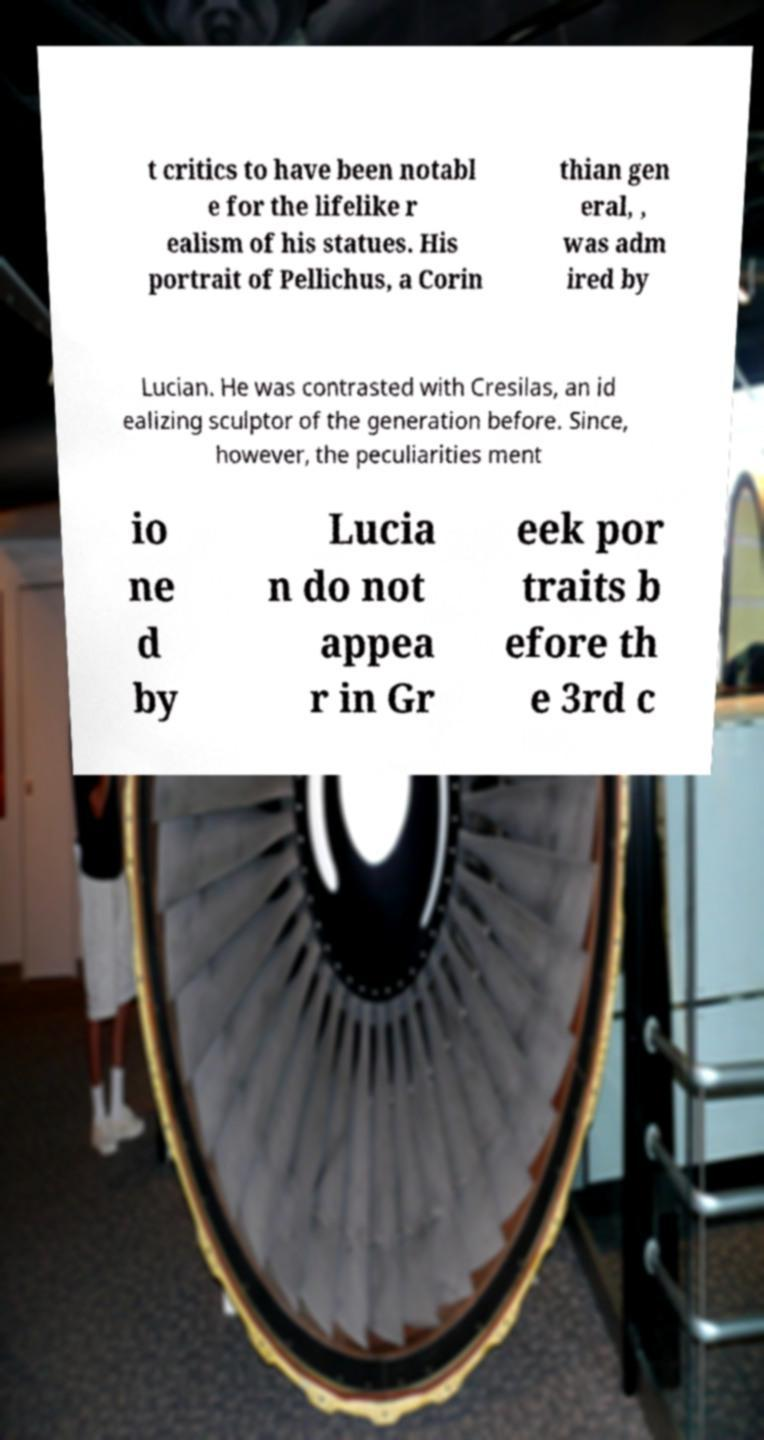Could you assist in decoding the text presented in this image and type it out clearly? t critics to have been notabl e for the lifelike r ealism of his statues. His portrait of Pellichus, a Corin thian gen eral, , was adm ired by Lucian. He was contrasted with Cresilas, an id ealizing sculptor of the generation before. Since, however, the peculiarities ment io ne d by Lucia n do not appea r in Gr eek por traits b efore th e 3rd c 